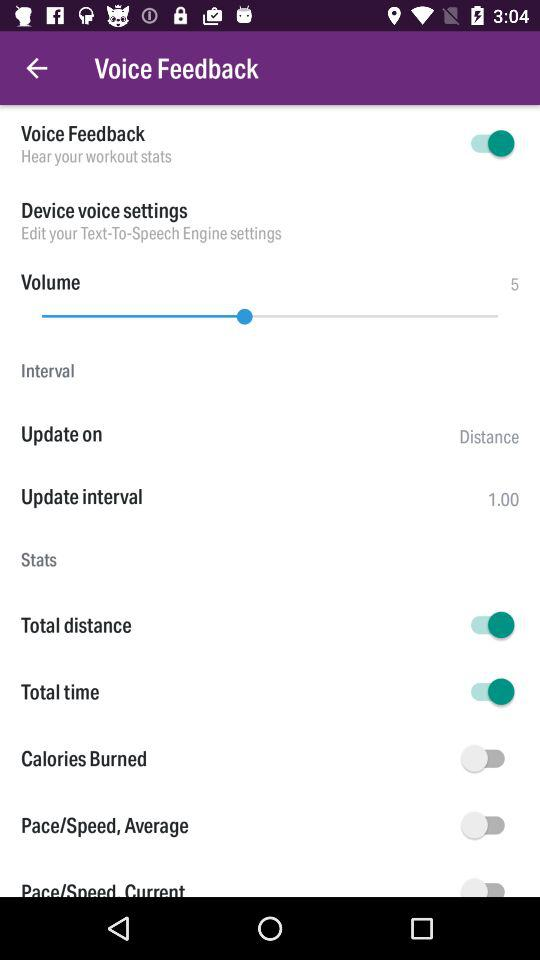What is the update interval? The update interval is 1.00. 